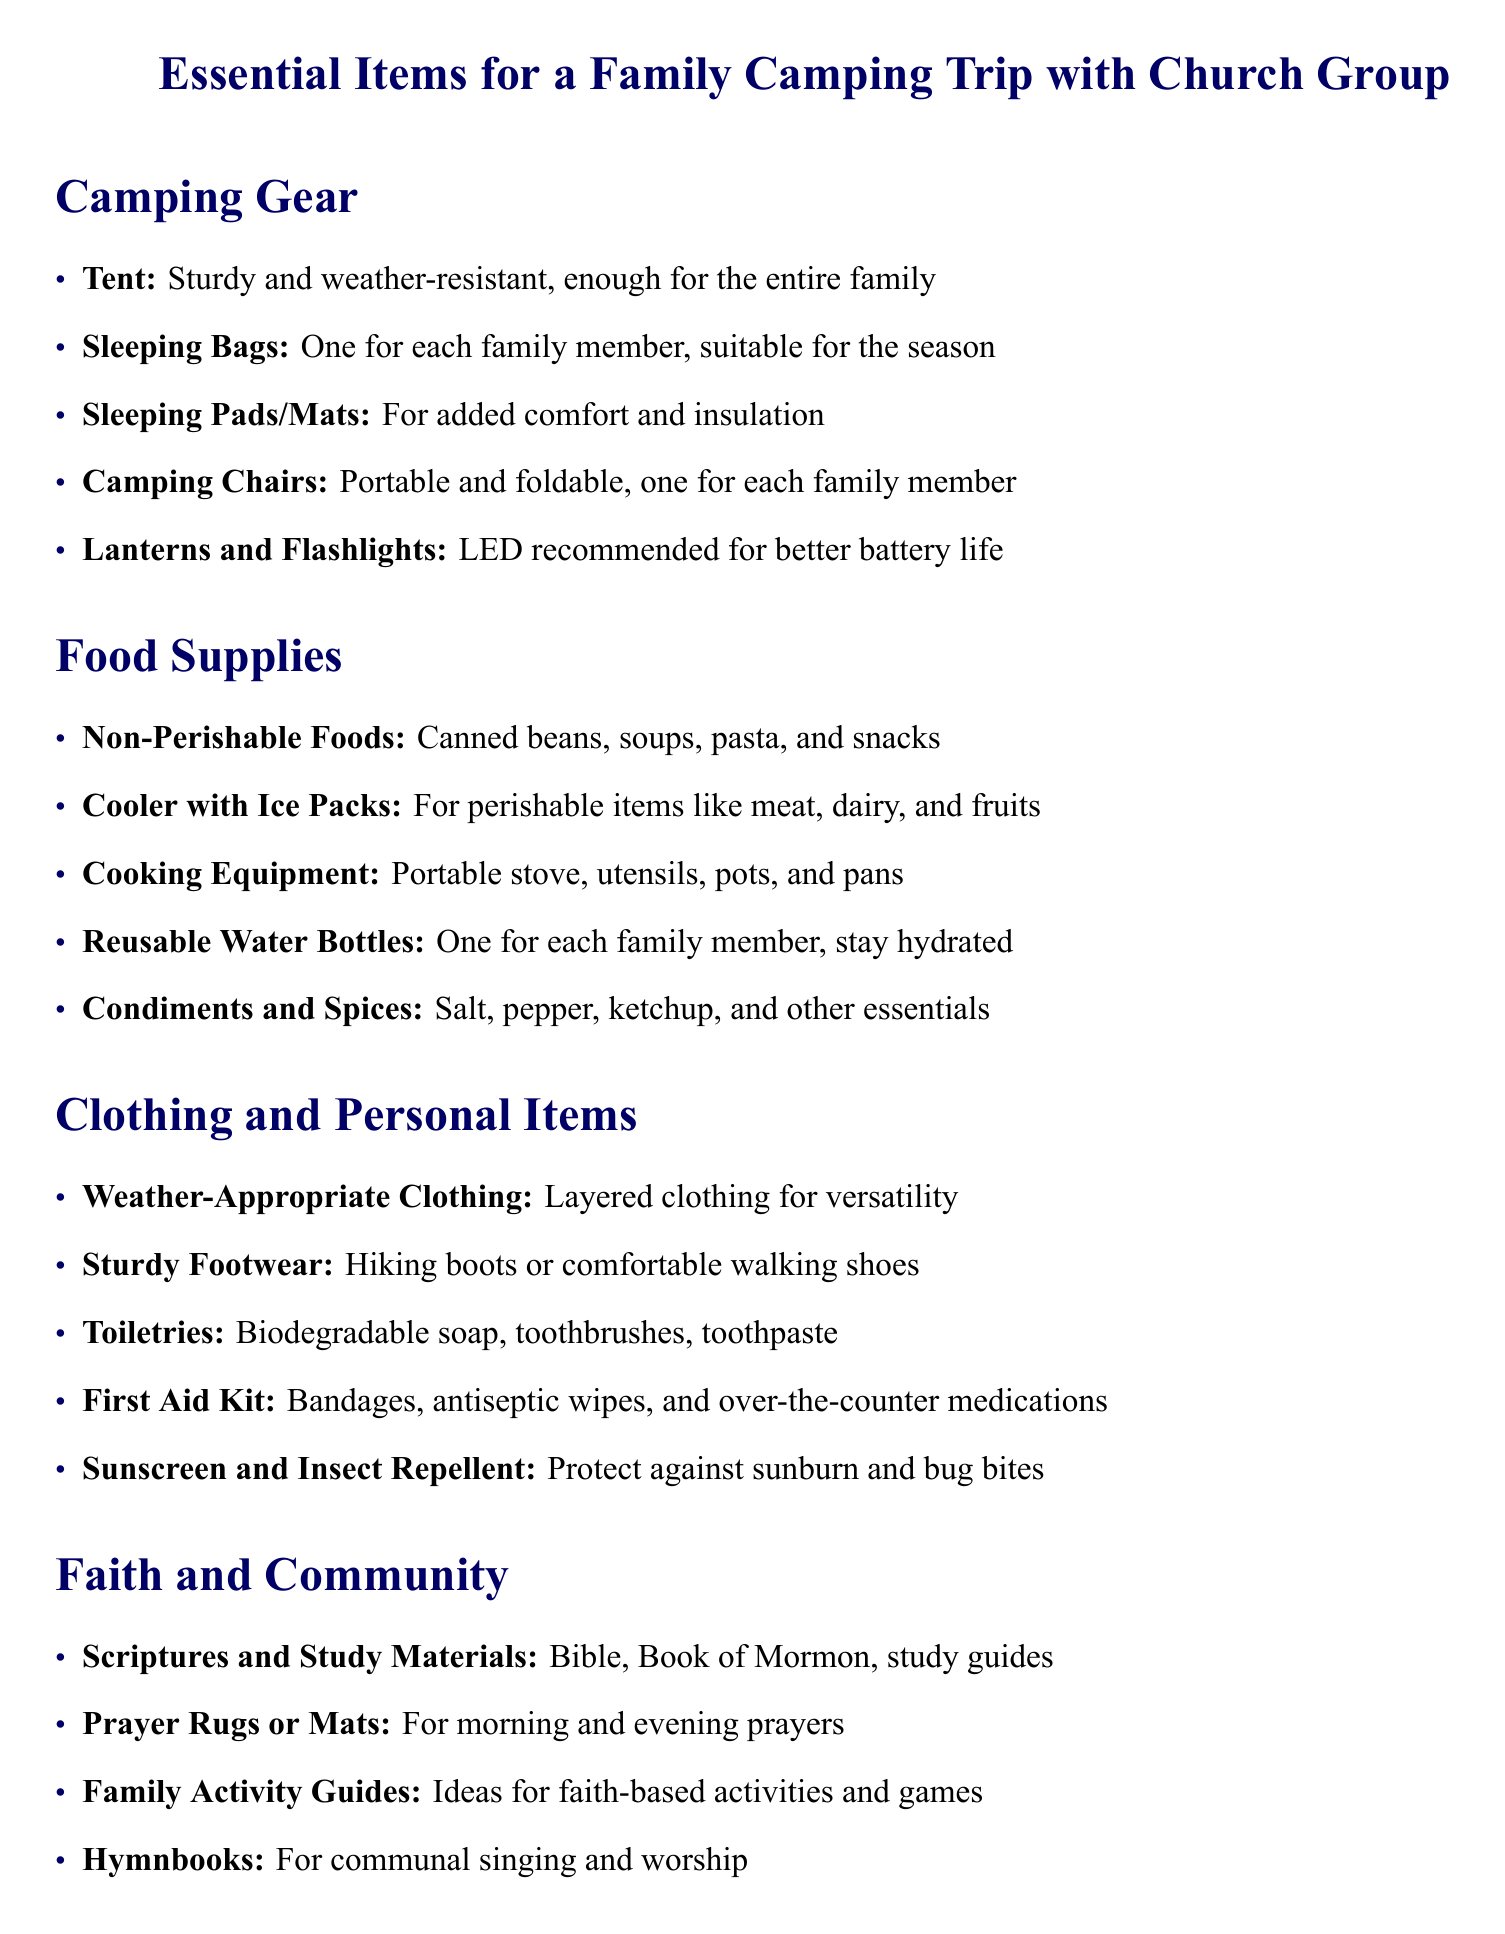What is the recommended attire for camping? The document mentions "Weather-Appropriate Clothing" as part of the clothing and personal items section.
Answer: Weather-Appropriate Clothing How many lanterns or flashlights are recommended? The packing list states "Lanterns and Flashlights: LED recommended for better battery life," implying a minimum of one is needed for each family member.
Answer: One for each family member What food category is suggested for cooking supplies? The food supplies section includes "Cooking Equipment: Portable stove, utensils, pots, and pans," indicating the type of food preparation gear required.
Answer: Cooking Equipment What essential item is listed for communal worship? Under the faith and community section, "Hymnbooks" are included as an essential for communal singing.
Answer: Hymnbooks How many family activity guides are mentioned? The document lists "Family Activity Guides" once in the list under the faith and community section, indicating a single mention.
Answer: One 